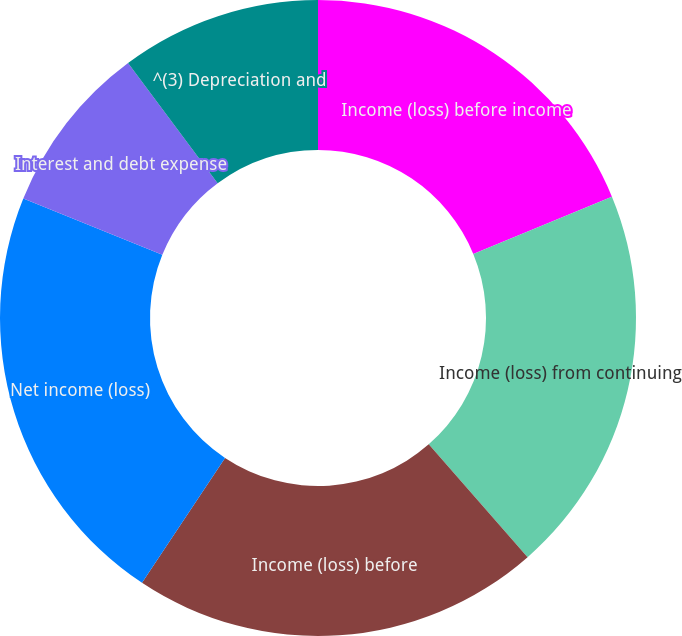Convert chart. <chart><loc_0><loc_0><loc_500><loc_500><pie_chart><fcel>Income (loss) before income<fcel>Income (loss) from continuing<fcel>Income (loss) before<fcel>Net income (loss)<fcel>Interest and debt expense<fcel>^(3) Depreciation and<nl><fcel>18.77%<fcel>19.78%<fcel>20.79%<fcel>21.8%<fcel>8.68%<fcel>10.19%<nl></chart> 